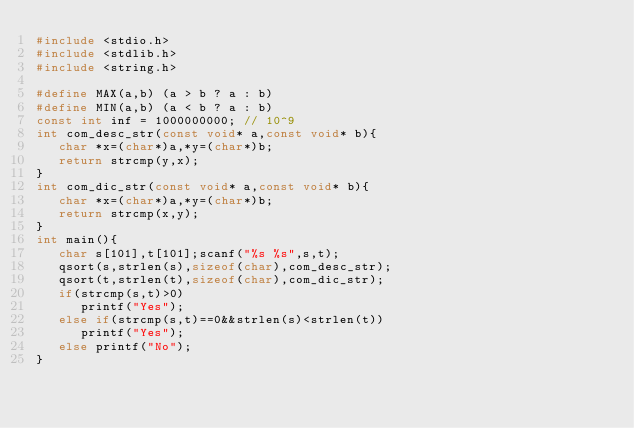<code> <loc_0><loc_0><loc_500><loc_500><_C_>#include <stdio.h>
#include <stdlib.h>
#include <string.h>

#define MAX(a,b) (a > b ? a : b)
#define MIN(a,b) (a < b ? a : b)
const int inf = 1000000000; // 10^9
int com_desc_str(const void* a,const void* b){
   char *x=(char*)a,*y=(char*)b;
   return strcmp(y,x);
} 
int com_dic_str(const void* a,const void* b){
   char *x=(char*)a,*y=(char*)b;
   return strcmp(x,y);
} 
int main(){
   char s[101],t[101];scanf("%s %s",s,t);
   qsort(s,strlen(s),sizeof(char),com_desc_str);
   qsort(t,strlen(t),sizeof(char),com_dic_str);
   if(strcmp(s,t)>0)
      printf("Yes");
   else if(strcmp(s,t)==0&&strlen(s)<strlen(t))
      printf("Yes");
   else printf("No");
}</code> 